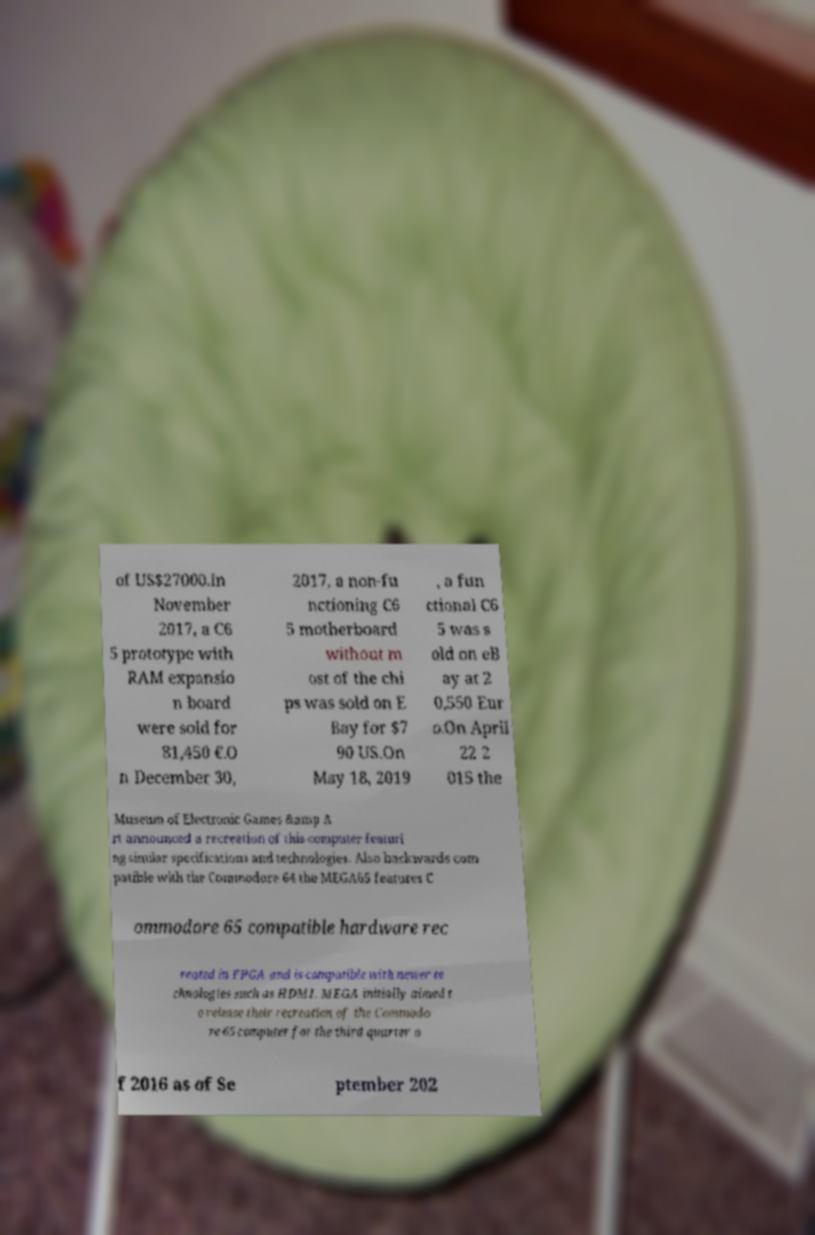Can you read and provide the text displayed in the image?This photo seems to have some interesting text. Can you extract and type it out for me? of US$27000.In November 2017, a C6 5 prototype with RAM expansio n board were sold for 81,450 €.O n December 30, 2017, a non-fu nctioning C6 5 motherboard without m ost of the chi ps was sold on E Bay for $7 90 US.On May 18, 2019 , a fun ctional C6 5 was s old on eB ay at 2 0,550 Eur o.On April 22 2 015 the Museum of Electronic Games &amp A rt announced a recreation of this computer featuri ng similar specifications and technologies. Also backwards com patible with the Commodore 64 the MEGA65 features C ommodore 65 compatible hardware rec reated in FPGA and is compatible with newer te chnologies such as HDMI. MEGA initially aimed t o release their recreation of the Commodo re 65 computer for the third quarter o f 2016 as of Se ptember 202 